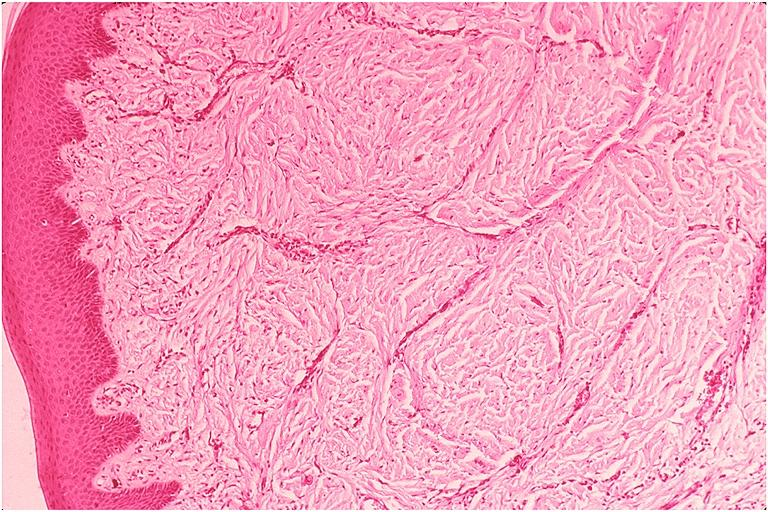what is present?
Answer the question using a single word or phrase. Oral 